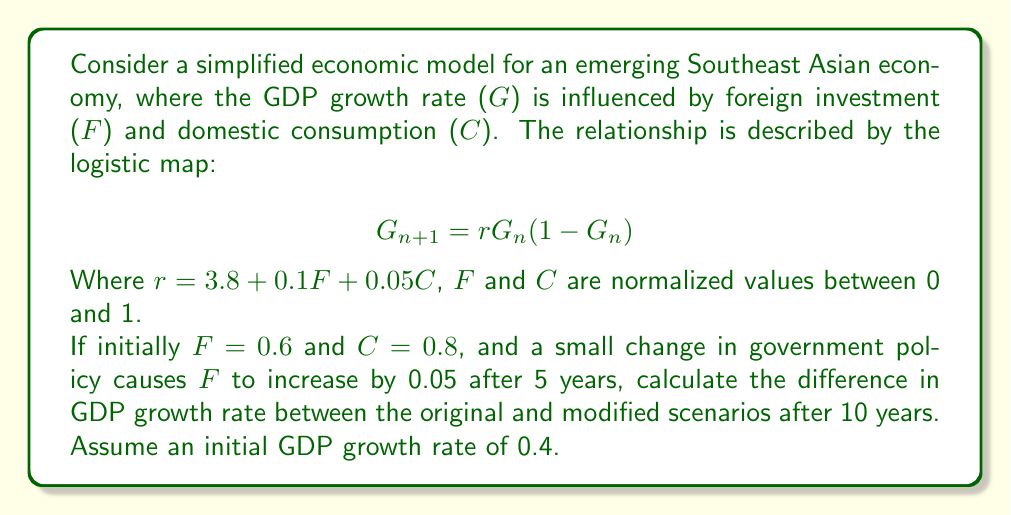Solve this math problem. Let's approach this step-by-step:

1) First, calculate the r value for the original scenario:
   $r_1 = 3.8 + 0.1(0.6) + 0.05(0.8) = 3.9$

2) For the modified scenario:
   $r_2 = 3.8 + 0.1(0.65) + 0.05(0.8) = 3.905$

3) Now, we need to iterate the logistic map for 10 years for both scenarios:

   Original scenario ($r_1 = 3.9$):
   $G_0 = 0.4$
   $G_1 = 3.9 * 0.4 * (1-0.4) = 0.936$
   $G_2 = 3.9 * 0.936 * (1-0.936) = 0.234$
   ...
   $G_{10} \approx 0.9447$

   Modified scenario ($r_2 = 3.905$):
   For the first 5 years, use $r_1 = 3.9$:
   $G_0 = 0.4$
   $G_1 = 3.9 * 0.4 * (1-0.4) = 0.936$
   $G_2 = 3.9 * 0.936 * (1-0.936) = 0.234$
   ...
   $G_5 \approx 0.9503$

   Then for the next 5 years, use $r_2 = 3.905$:
   $G_6 = 3.905 * 0.9503 * (1-0.9503) = 0.1833$
   ...
   $G_{10} \approx 0.9662$

4) Calculate the difference:
   $0.9662 - 0.9447 = 0.0215$

This demonstrates the butterfly effect: a small change in foreign investment led to a noticeable difference in GDP growth rate after 10 years.
Answer: 0.0215 